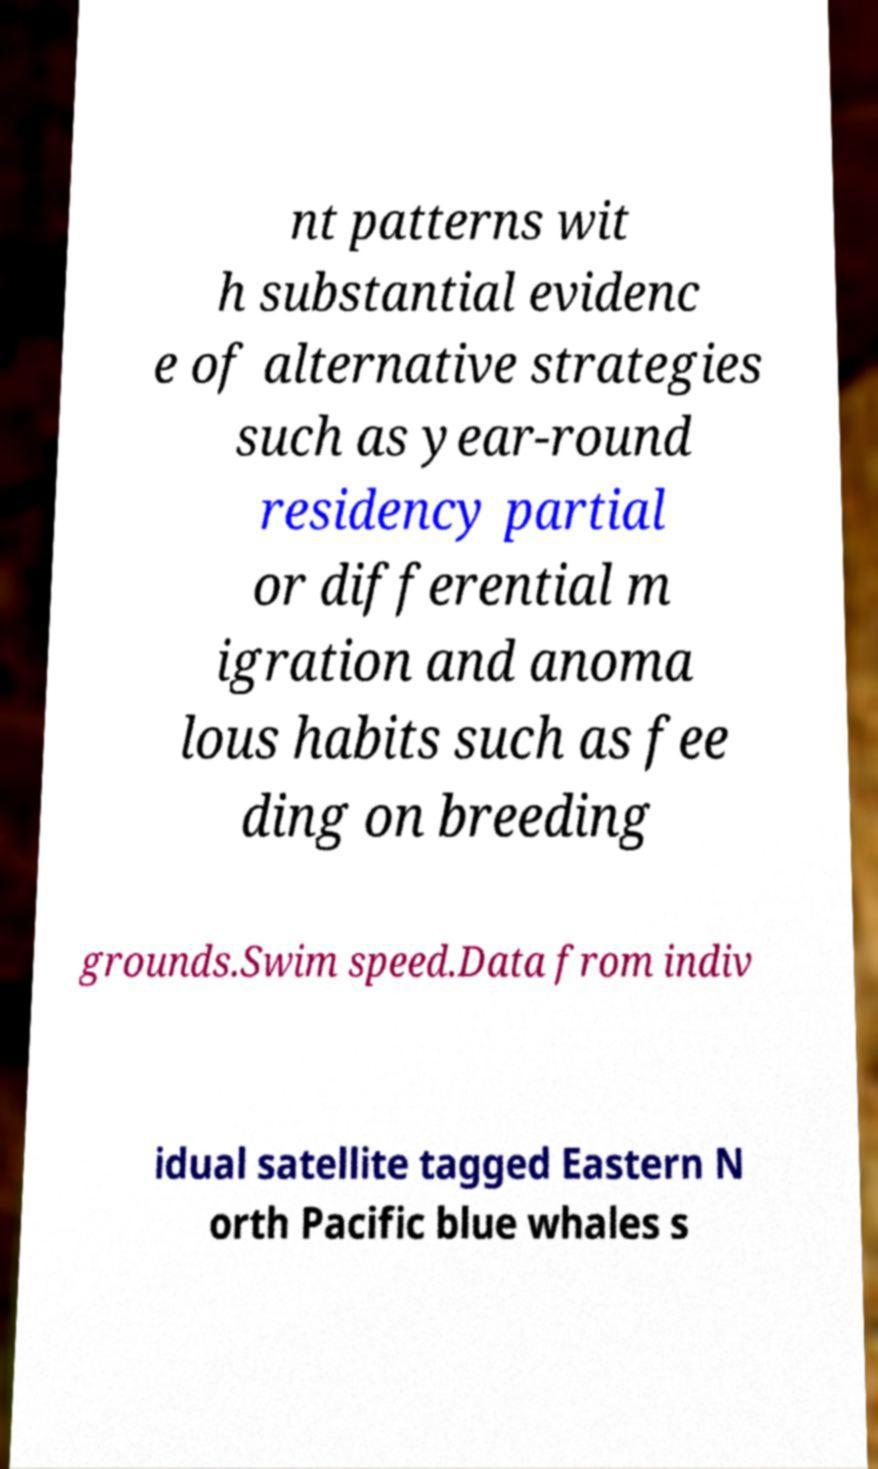Can you read and provide the text displayed in the image?This photo seems to have some interesting text. Can you extract and type it out for me? nt patterns wit h substantial evidenc e of alternative strategies such as year-round residency partial or differential m igration and anoma lous habits such as fee ding on breeding grounds.Swim speed.Data from indiv idual satellite tagged Eastern N orth Pacific blue whales s 